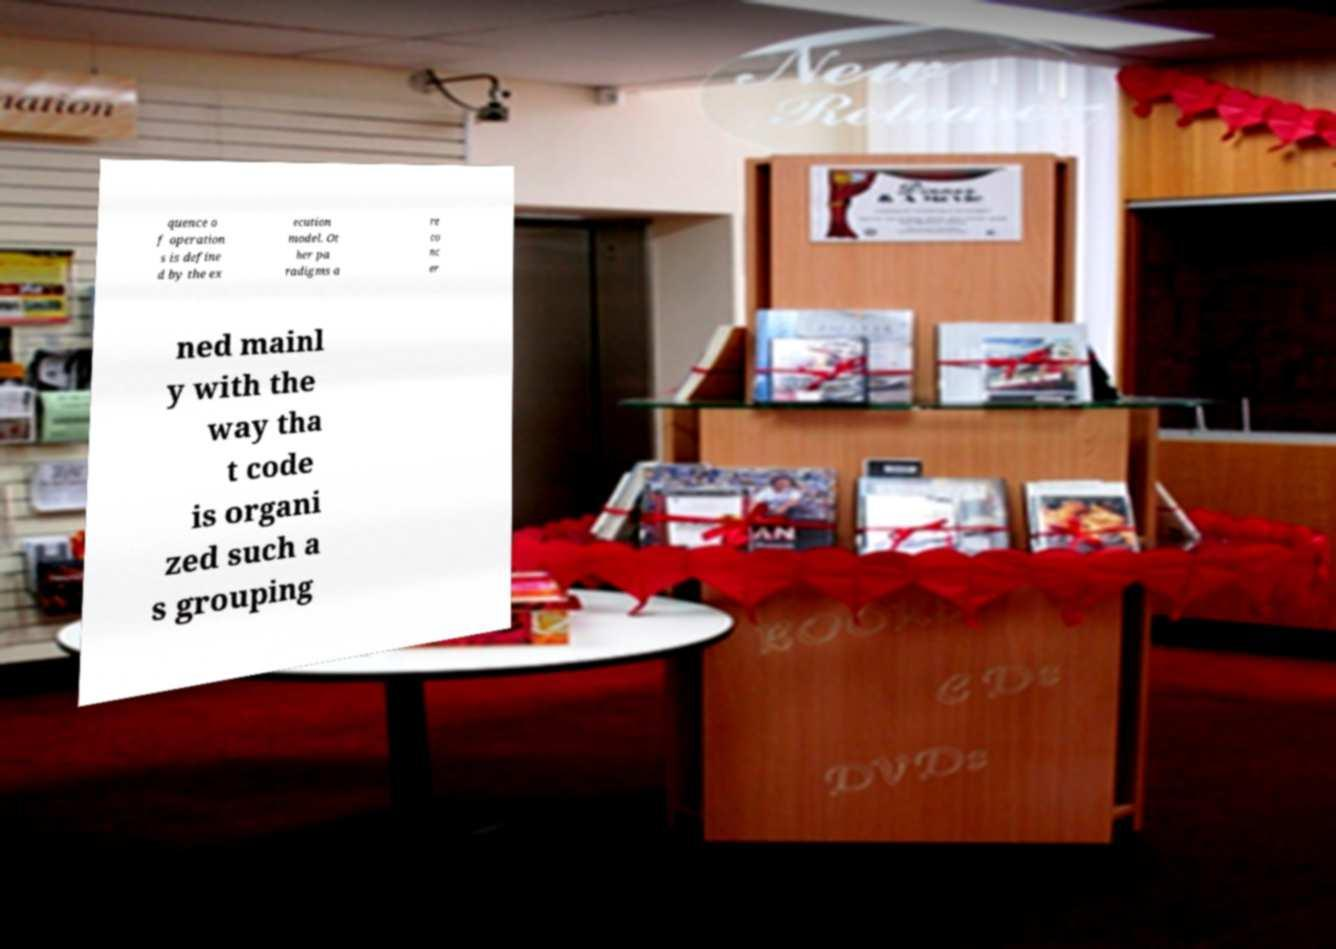Could you assist in decoding the text presented in this image and type it out clearly? quence o f operation s is define d by the ex ecution model. Ot her pa radigms a re co nc er ned mainl y with the way tha t code is organi zed such a s grouping 